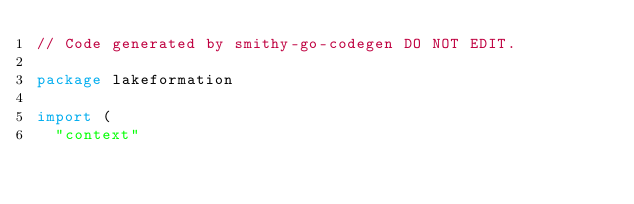<code> <loc_0><loc_0><loc_500><loc_500><_Go_>// Code generated by smithy-go-codegen DO NOT EDIT.

package lakeformation

import (
	"context"</code> 